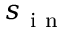Convert formula to latex. <formula><loc_0><loc_0><loc_500><loc_500>s _ { i n }</formula> 